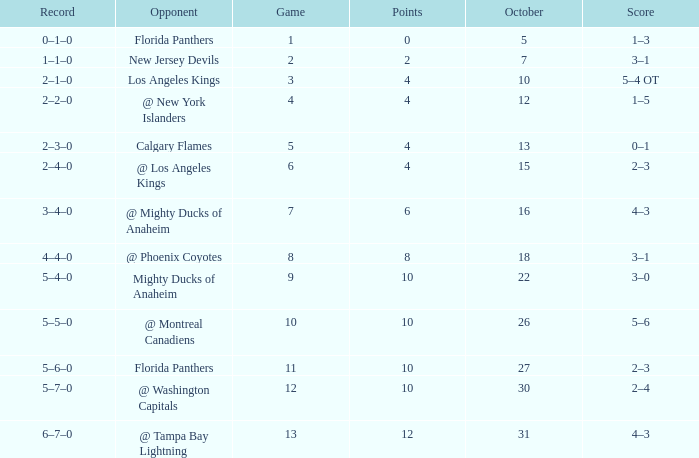What team has a score of 11 5–6–0. 